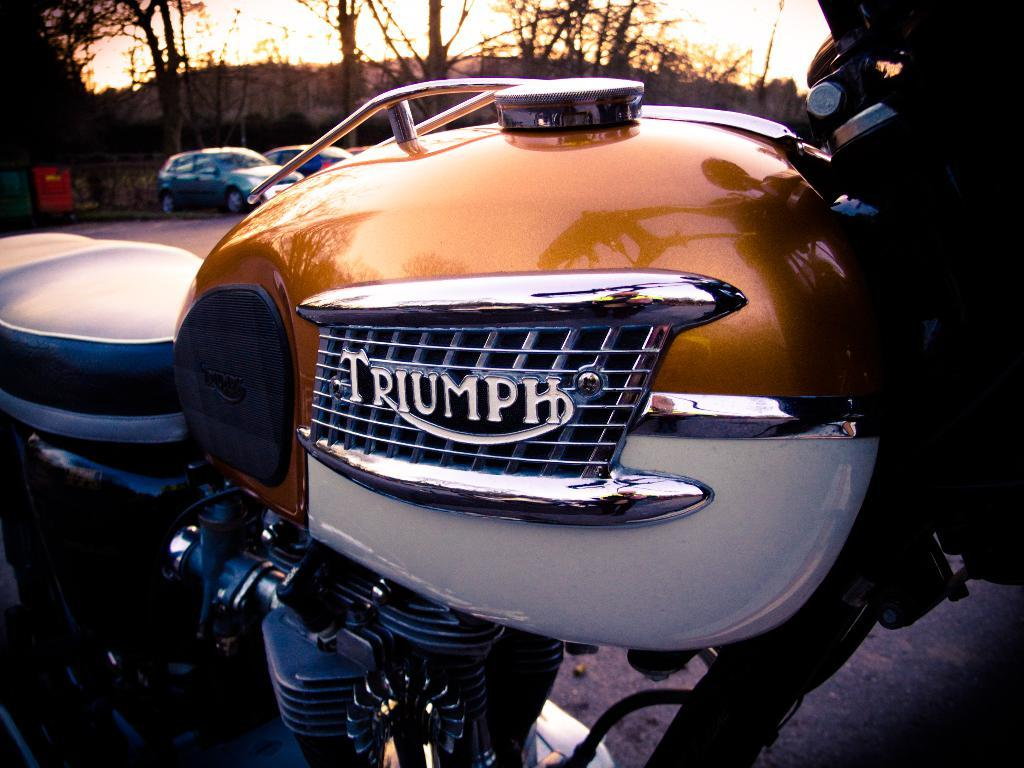What is the main subject in the foreground of the image? There is a truncated motorbike in the foreground of the image. What can be seen in the background of the image? There are two cars on the road and trees visible in the background of the image. What else is visible in the background of the image? The sky is visible in the background of the image. What type of brick is being used to build the appliance in the image? There is no brick or appliance present in the image. Can you tell me how many parents are visible in the image? There are no parents visible in the image. 